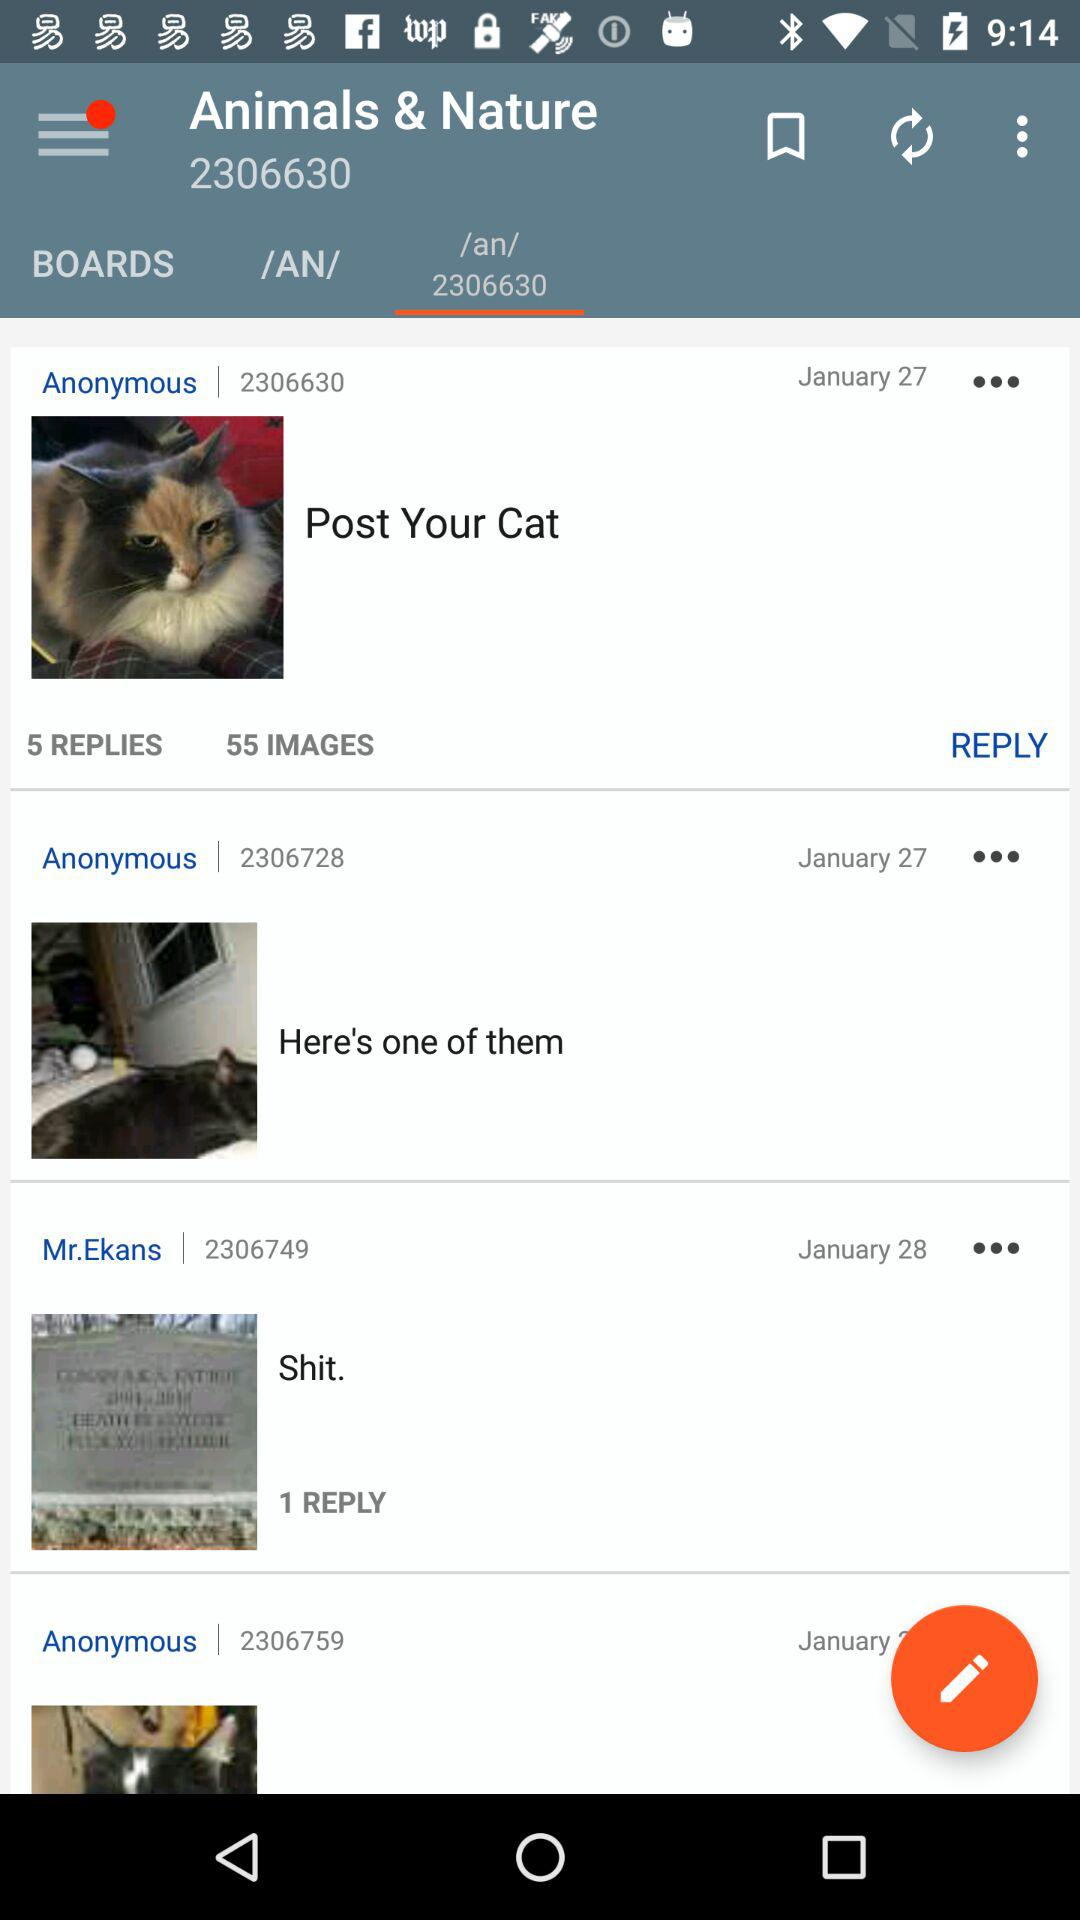Which tab is selected in "Animals and Nature"? The selected tab is "/an/ 2306630". 